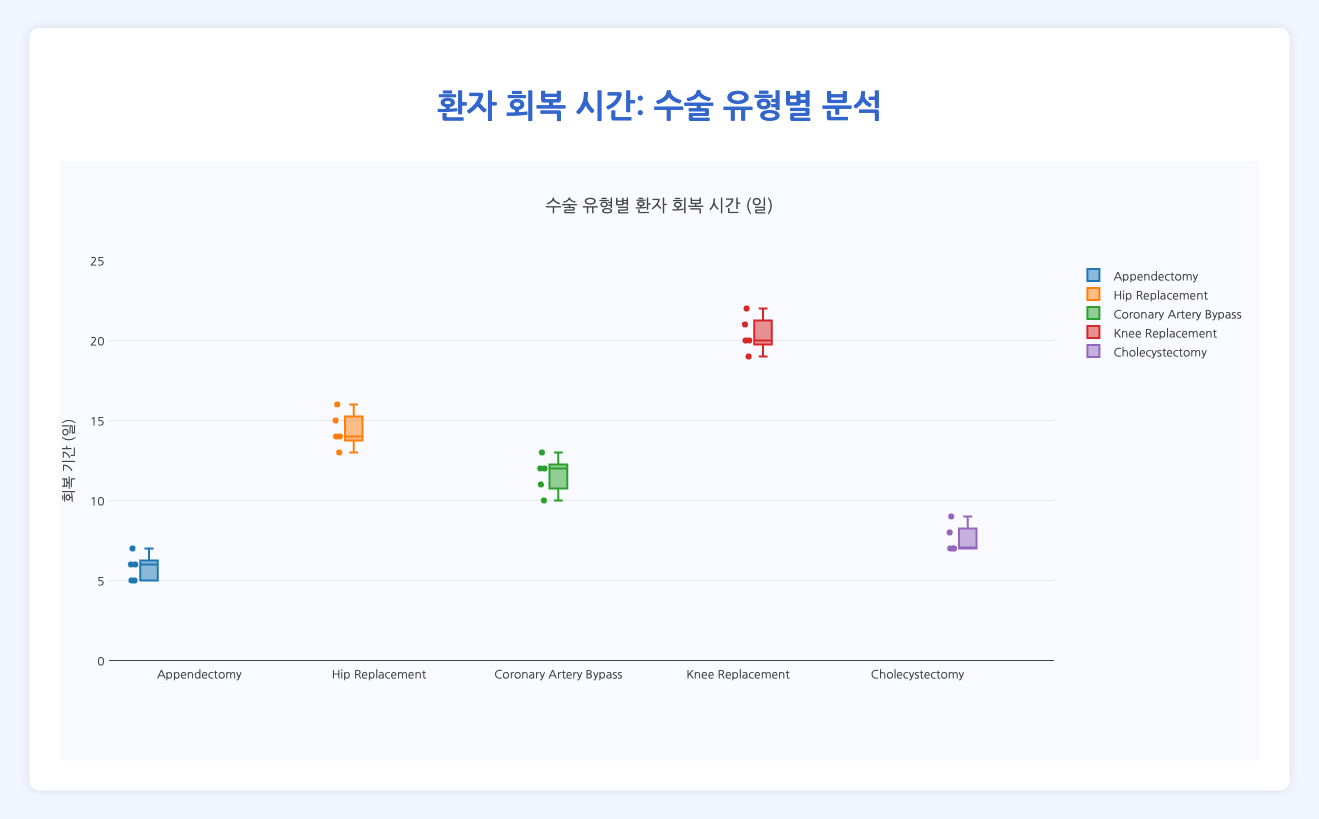What is the title of the figure? The title of the figure can be seen at the top center of the plot. It provides a summary of what the figure represents.
Answer: 환자 회복 시간: 수술 유형별 분석 What is the recovery time range on the y-axis? The y-axis represents the recovery time measured in days, which can be observed on the left side of the figure.
Answer: 0 to 25 days Which surgery type has the shortest median recovery time? To determine the median recovery time, look for the line inside the box (the median) for each surgery type. The surgery type with the shortest median line is the answer.
Answer: Appendectomy Which hospital has the highest recovery time for Cholecystectomy? Find the recovery times for Cholecystectomy, and identify the hospital with the highest value.
Answer: Yonsei Severance Hospital What is the range of recovery times for Knee Replacement surgeries? The range of recovery times can be determined by subtracting the smallest value (the lower whisker) from the largest value (the upper whisker) of the Knee Replacement box plot.
Answer: 19 to 22 days How does the median recovery time for Hip Replacement compare to that of Coronary Artery Bypass? Compare the median lines within the boxes for Hip Replacement and Coronary Artery Bypass. Look for which appears higher or lower on the y-axis.
Answer: Higher for Hip Replacement What is the interquartile range (IQR) for Coronary Artery Bypass recovery times? The IQR is given by the difference between the upper quartile (the top of the box) and the lower quartile (the bottom of the box) for Coronary Artery Bypass.
Answer: 11 to 12 days Which surgery type appears to have the most consistent recovery times? Consistency can be understood as having a smaller range from the lowest to the highest values (whiskers). Identify the surgery type with the smallest spread.
Answer: Cholecystectomy Identify the surgery type with the broadest variability in recovery times. Variability is indicated by the largest range from the minimum to the maximum value. The surgery type with the widest whiskers has the most variability.
Answer: Knee Replacement 